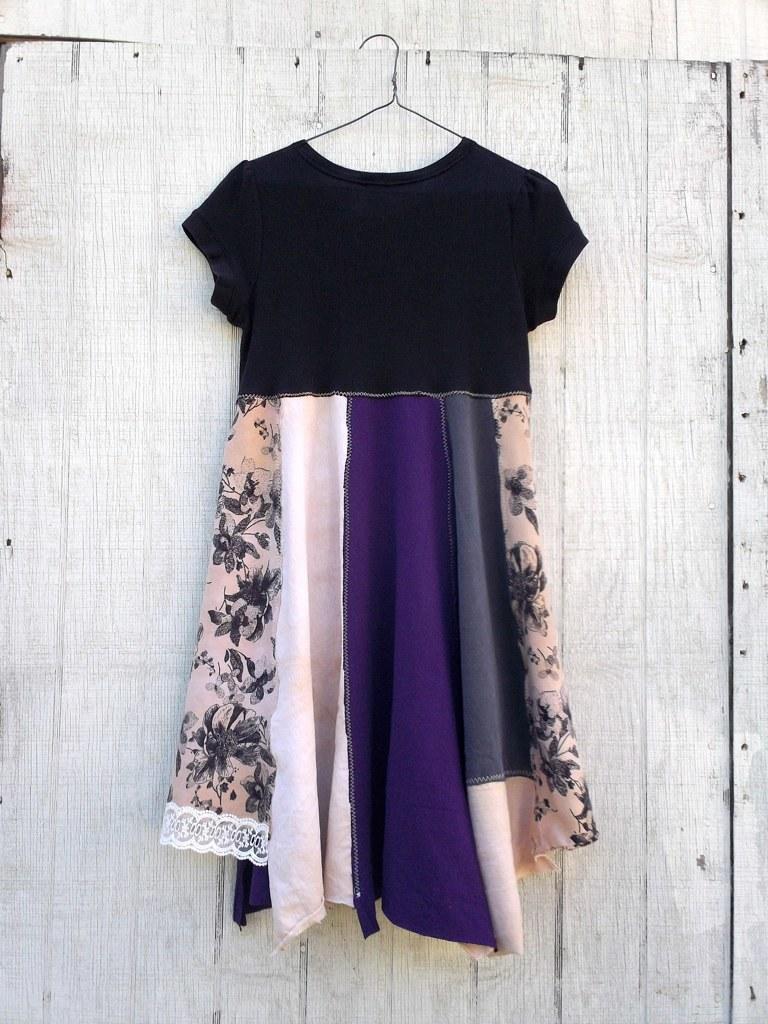In one or two sentences, can you explain what this image depicts? In this image we can see a dress and the hanger. In the background, we can see wooden wall. 